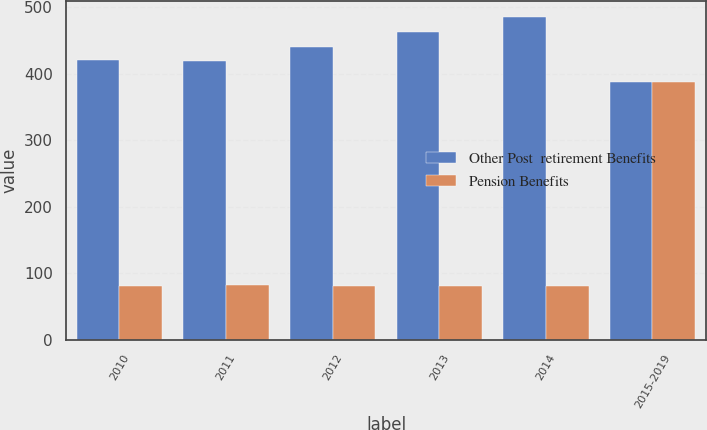<chart> <loc_0><loc_0><loc_500><loc_500><stacked_bar_chart><ecel><fcel>2010<fcel>2011<fcel>2012<fcel>2013<fcel>2014<fcel>2015-2019<nl><fcel>Other Post  retirement Benefits<fcel>420<fcel>419<fcel>440<fcel>463<fcel>485<fcel>388<nl><fcel>Pension Benefits<fcel>81<fcel>82<fcel>81<fcel>81<fcel>80<fcel>388<nl></chart> 